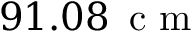<formula> <loc_0><loc_0><loc_500><loc_500>9 1 . 0 8 \, c m</formula> 